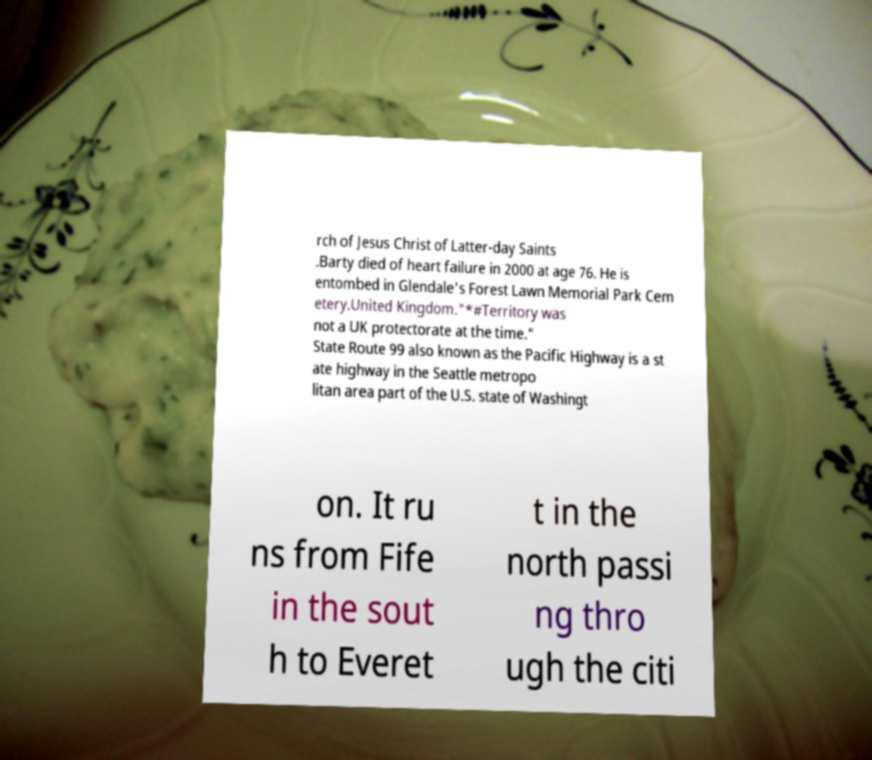For documentation purposes, I need the text within this image transcribed. Could you provide that? rch of Jesus Christ of Latter-day Saints .Barty died of heart failure in 2000 at age 76. He is entombed in Glendale's Forest Lawn Memorial Park Cem etery.United Kingdom."*#Territory was not a UK protectorate at the time." State Route 99 also known as the Pacific Highway is a st ate highway in the Seattle metropo litan area part of the U.S. state of Washingt on. It ru ns from Fife in the sout h to Everet t in the north passi ng thro ugh the citi 